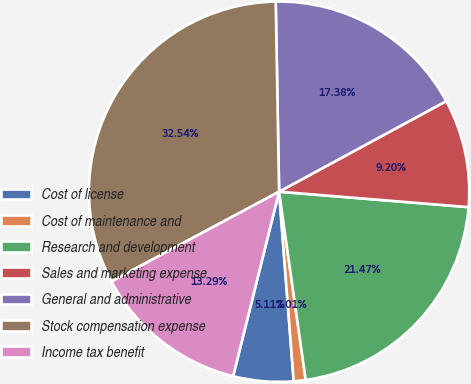<chart> <loc_0><loc_0><loc_500><loc_500><pie_chart><fcel>Cost of license<fcel>Cost of maintenance and<fcel>Research and development<fcel>Sales and marketing expense<fcel>General and administrative<fcel>Stock compensation expense<fcel>Income tax benefit<nl><fcel>5.11%<fcel>1.01%<fcel>21.47%<fcel>9.2%<fcel>17.38%<fcel>32.54%<fcel>13.29%<nl></chart> 